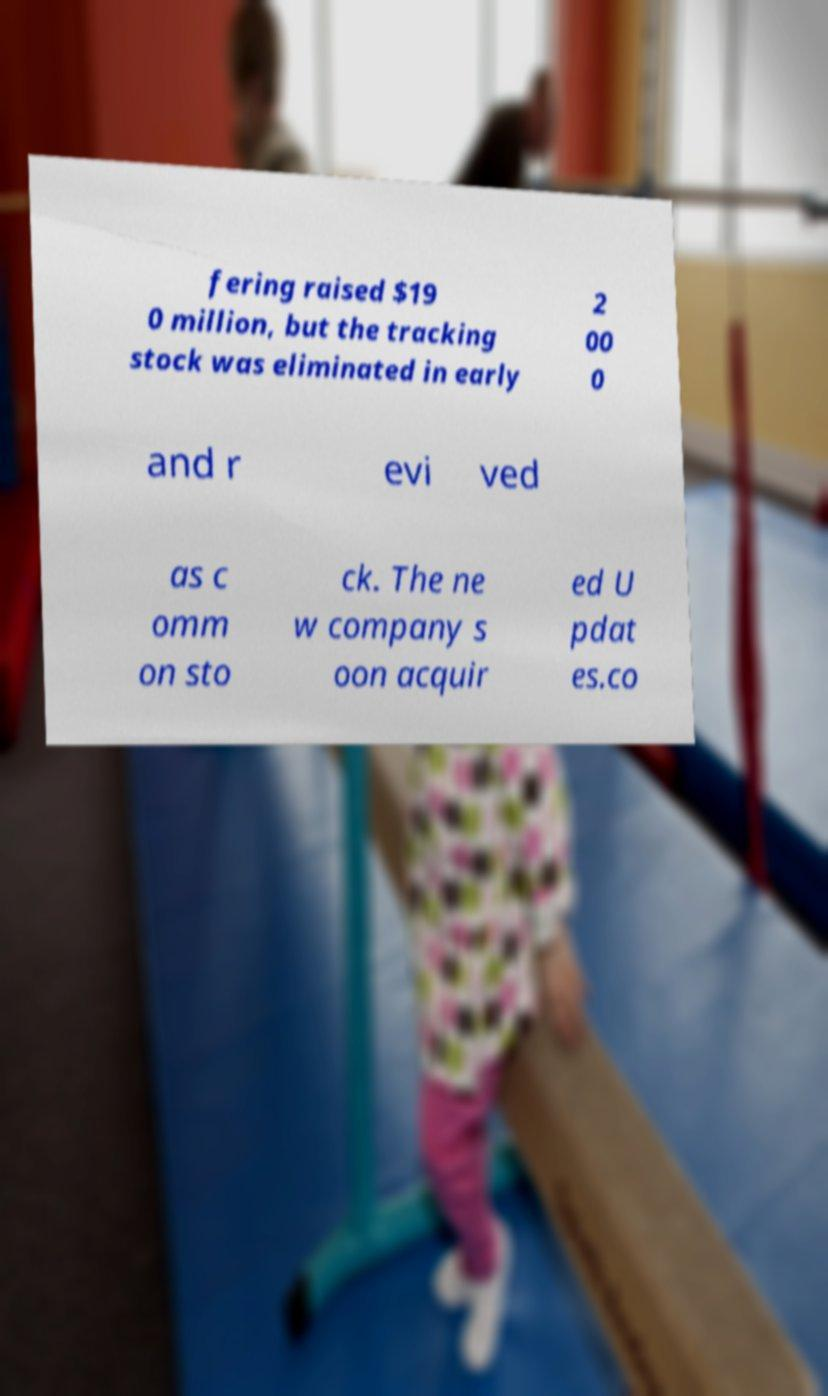Could you assist in decoding the text presented in this image and type it out clearly? fering raised $19 0 million, but the tracking stock was eliminated in early 2 00 0 and r evi ved as c omm on sto ck. The ne w company s oon acquir ed U pdat es.co 